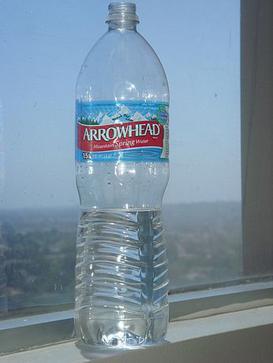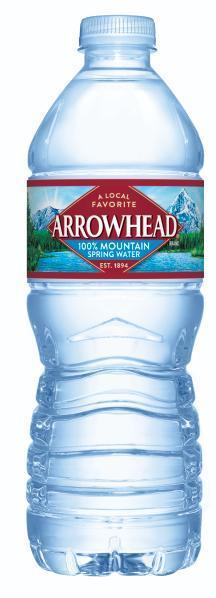The first image is the image on the left, the second image is the image on the right. For the images displayed, is the sentence "Right and left images show a similarly shaped and sized non-stout bottle with a label and a white cap." factually correct? Answer yes or no. No. The first image is the image on the left, the second image is the image on the right. Assess this claim about the two images: "There are two nearly identical bottles of water.". Correct or not? Answer yes or no. Yes. 